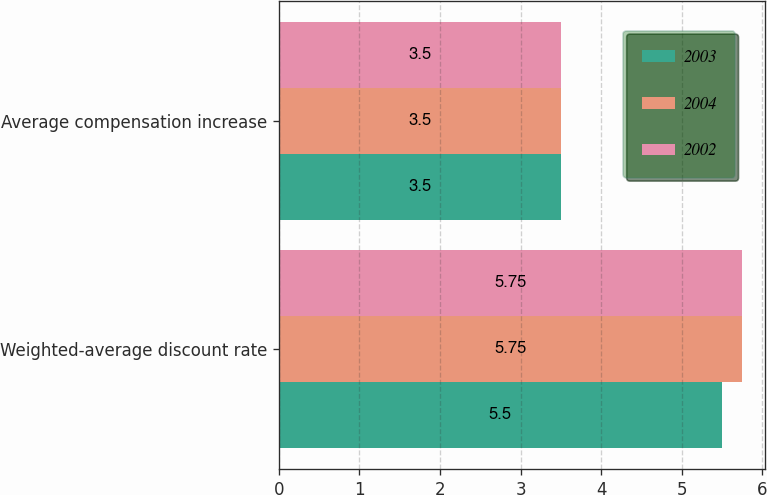Convert chart. <chart><loc_0><loc_0><loc_500><loc_500><stacked_bar_chart><ecel><fcel>Weighted-average discount rate<fcel>Average compensation increase<nl><fcel>2003<fcel>5.5<fcel>3.5<nl><fcel>2004<fcel>5.75<fcel>3.5<nl><fcel>2002<fcel>5.75<fcel>3.5<nl></chart> 